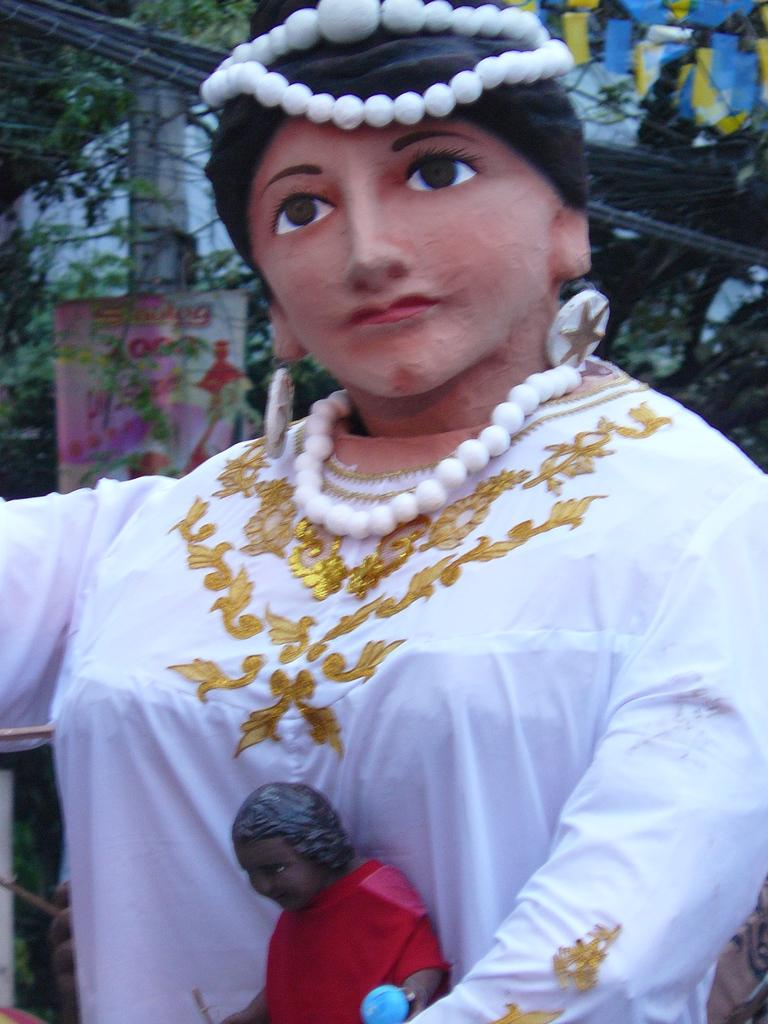What is the main subject in the image? There is a statue in the image. What can be seen in the background of the image? There is a pole, a flexi, and trees in the background of the image. What else is visible in the image? Cables are visible in the image. What type of cheese is being used to decorate the cakes in the image? There are no cakes or cheese present in the image. What color are the trousers worn by the statue in the image? The statue in the image is not a person, so it does not wear trousers. 